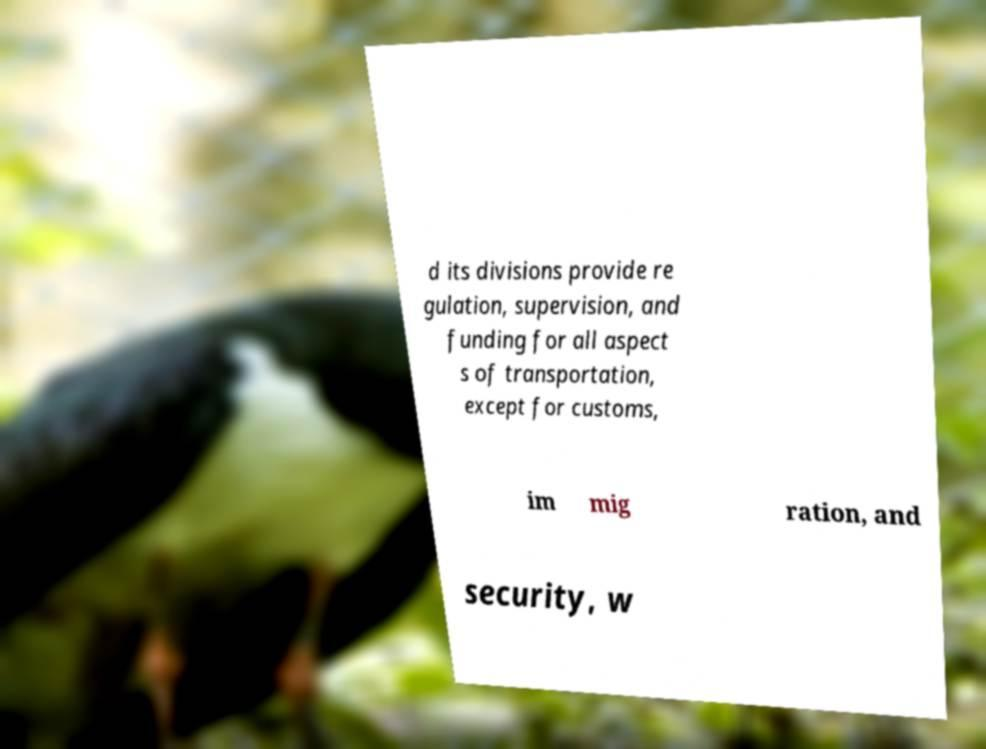What messages or text are displayed in this image? I need them in a readable, typed format. d its divisions provide re gulation, supervision, and funding for all aspect s of transportation, except for customs, im mig ration, and security, w 